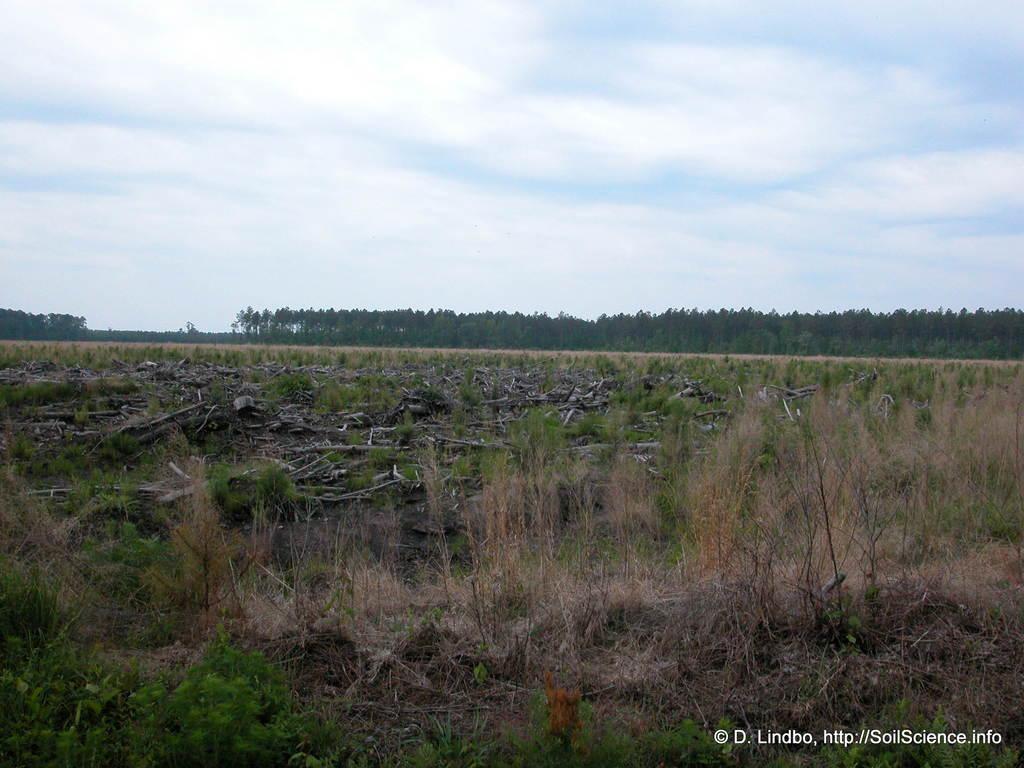How would you summarize this image in a sentence or two? In the foreground of the picture there are plants and grass. In the center of the picture there are plants and wooden blocks. In the background there are trees. Sky is cloudy. 